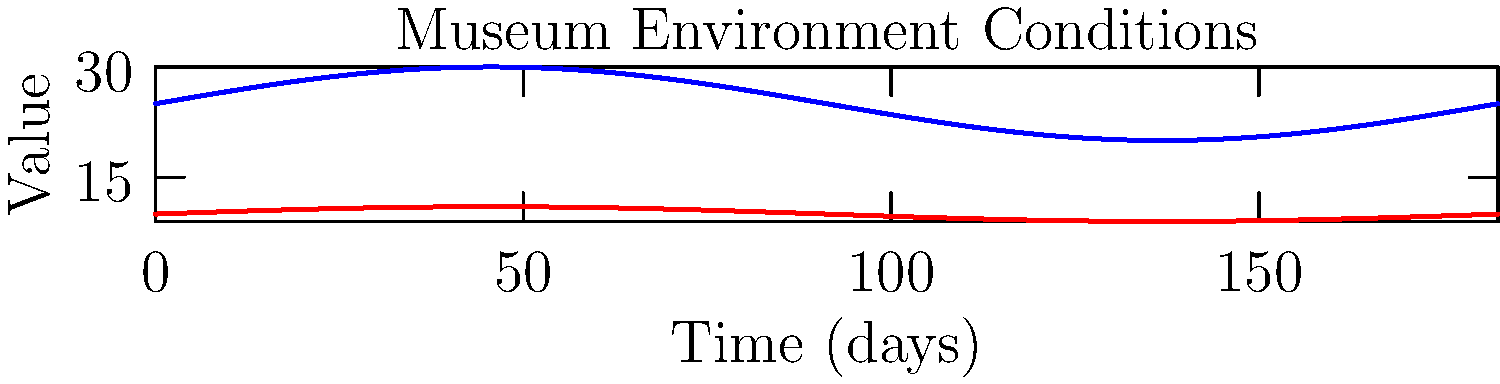As an art critic interested in preservation techniques, you're analyzing the environmental conditions in a prestigious museum housing Italian Renaissance paintings. The graph shows temperature and relative humidity fluctuations over a year. Given that sudden changes in these parameters can cause damage to artworks, which season appears to pose the greatest risk to the paintings, and why? To answer this question, we need to analyze the graph and understand the impact of temperature and humidity fluctuations on artworks:

1. Observe the graph: The red line represents temperature, and the blue line represents relative humidity over a year (365 days).

2. Identify the seasons: The graph shows one complete cycle, representing a year. We can assume that the peaks correspond to summer and the troughs to winter.

3. Analyze the fluctuations:
   a. Temperature: Varies between approximately 18°C and 22°C.
   b. Relative Humidity: Varies between approximately 40% and 60%.

4. Consider the rate of change: The steepest slopes in both lines indicate the fastest rate of change.

5. Locate the areas of rapid change: The most significant changes occur during the transitions between seasons, particularly between summer and fall, and between winter and spring.

6. Assess the risk: Rapid changes in temperature and humidity can cause materials in artworks to expand or contract quickly, leading to cracking, warping, or other forms of damage.

7. Identify the riskiest period: The transition from summer to fall (around day 200-250 on the graph) shows the most rapid simultaneous decrease in both temperature and humidity, making it the most dangerous period for the artworks.
Answer: Fall (summer to fall transition) 